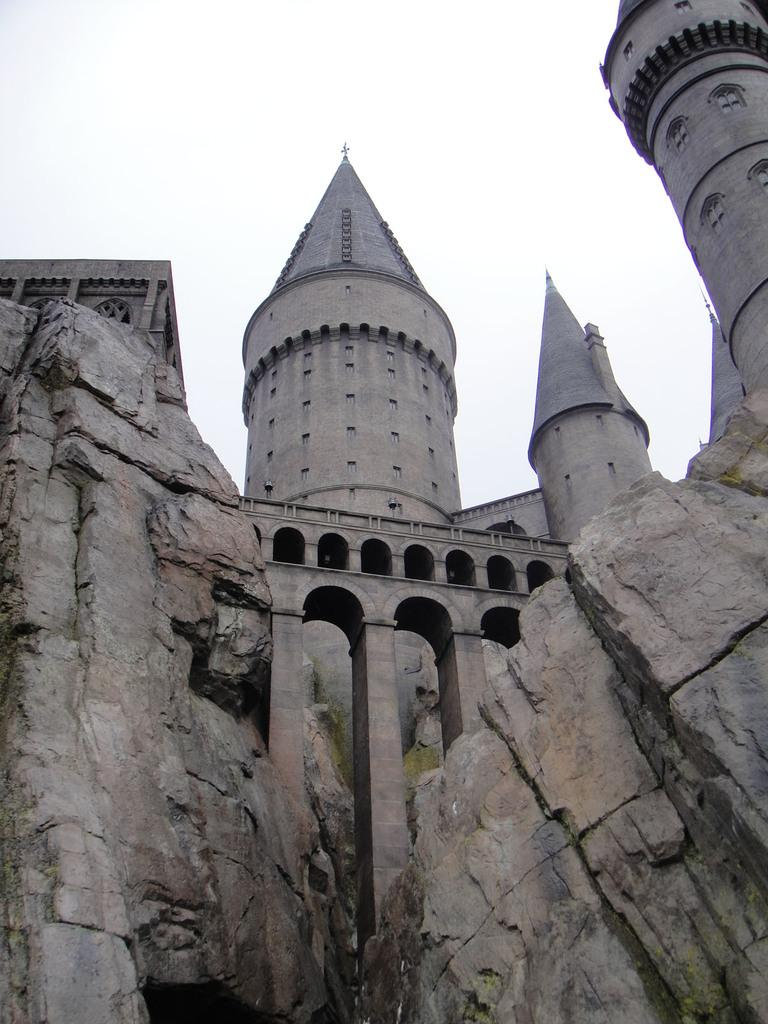What type of structure is visible in the image? There is a fort in the image. What can be seen in the foreground of the image? There are rocks in the foreground of the image. Is there any man-made structure connecting the rocks? Yes, there is a bridge across the rocks. What is visible at the top of the image? The sky is visible at the top of the image. What type of growth can be seen on the rocks? There is algae on the rocks. Can you hear the dinosaurs roaring in the image? There are no dinosaurs present in the image, so it is not possible to hear them roaring. Is there a volleyball game happening in the image? There is no volleyball game depicted in the image. 